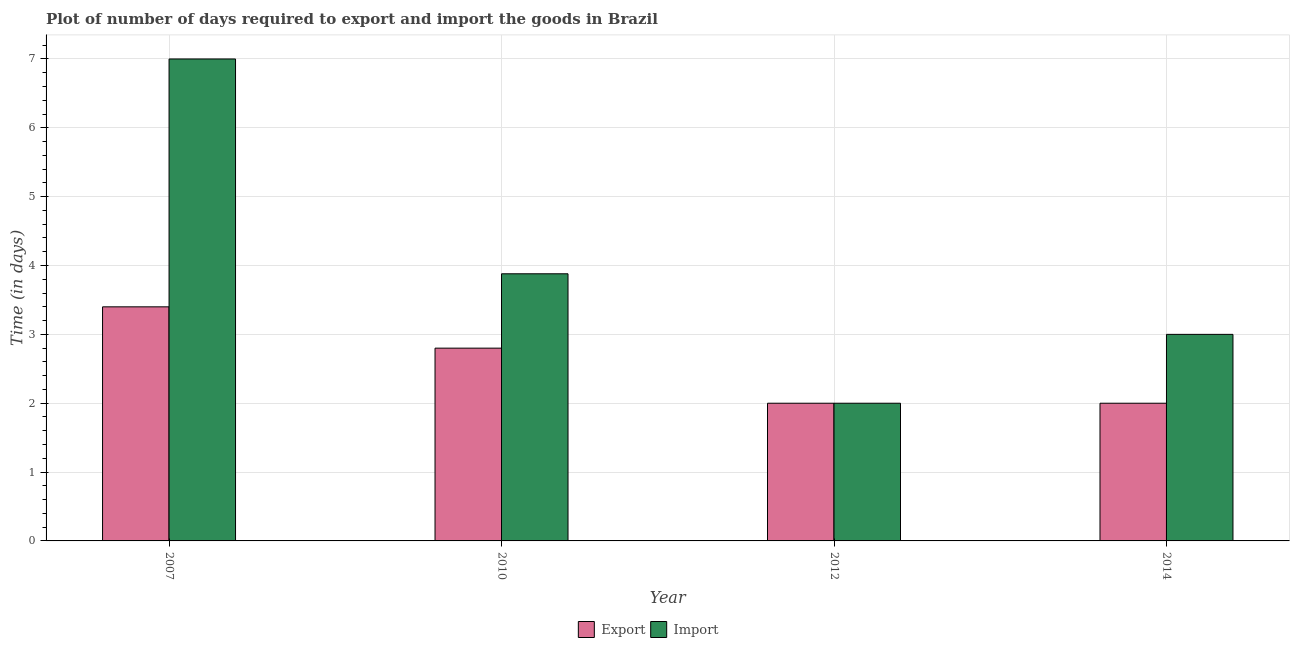How many different coloured bars are there?
Make the answer very short. 2. How many bars are there on the 2nd tick from the left?
Provide a succinct answer. 2. How many bars are there on the 1st tick from the right?
Give a very brief answer. 2. In how many cases, is the number of bars for a given year not equal to the number of legend labels?
Offer a terse response. 0. What is the time required to export in 2010?
Provide a succinct answer. 2.8. Across all years, what is the maximum time required to import?
Provide a short and direct response. 7. In which year was the time required to export minimum?
Your answer should be very brief. 2012. What is the total time required to import in the graph?
Provide a short and direct response. 15.88. What is the difference between the time required to import in 2007 and that in 2010?
Offer a terse response. 3.12. What is the difference between the time required to export in 2014 and the time required to import in 2010?
Provide a succinct answer. -0.8. What is the average time required to import per year?
Your answer should be very brief. 3.97. In the year 2007, what is the difference between the time required to import and time required to export?
Your answer should be very brief. 0. In how many years, is the time required to export greater than 4.8 days?
Give a very brief answer. 0. Is the time required to export in 2007 less than that in 2014?
Offer a very short reply. No. Is the difference between the time required to import in 2012 and 2014 greater than the difference between the time required to export in 2012 and 2014?
Provide a succinct answer. No. What is the difference between the highest and the second highest time required to export?
Provide a short and direct response. 0.6. What is the difference between the highest and the lowest time required to import?
Offer a very short reply. 5. In how many years, is the time required to export greater than the average time required to export taken over all years?
Make the answer very short. 2. What does the 1st bar from the left in 2007 represents?
Your answer should be very brief. Export. What does the 2nd bar from the right in 2010 represents?
Make the answer very short. Export. Are all the bars in the graph horizontal?
Offer a terse response. No. How many years are there in the graph?
Make the answer very short. 4. Does the graph contain any zero values?
Your answer should be very brief. No. Does the graph contain grids?
Provide a succinct answer. Yes. How are the legend labels stacked?
Give a very brief answer. Horizontal. What is the title of the graph?
Offer a very short reply. Plot of number of days required to export and import the goods in Brazil. Does "Researchers" appear as one of the legend labels in the graph?
Make the answer very short. No. What is the label or title of the Y-axis?
Provide a short and direct response. Time (in days). What is the Time (in days) of Import in 2007?
Your response must be concise. 7. What is the Time (in days) of Export in 2010?
Make the answer very short. 2.8. What is the Time (in days) of Import in 2010?
Your answer should be compact. 3.88. What is the Time (in days) in Export in 2014?
Keep it short and to the point. 2. Across all years, what is the maximum Time (in days) in Import?
Your answer should be very brief. 7. Across all years, what is the minimum Time (in days) of Export?
Your response must be concise. 2. What is the total Time (in days) in Export in the graph?
Offer a very short reply. 10.2. What is the total Time (in days) of Import in the graph?
Make the answer very short. 15.88. What is the difference between the Time (in days) of Import in 2007 and that in 2010?
Your answer should be compact. 3.12. What is the difference between the Time (in days) of Import in 2007 and that in 2012?
Provide a short and direct response. 5. What is the difference between the Time (in days) of Export in 2010 and that in 2012?
Offer a terse response. 0.8. What is the difference between the Time (in days) of Import in 2010 and that in 2012?
Provide a succinct answer. 1.88. What is the difference between the Time (in days) of Import in 2010 and that in 2014?
Your response must be concise. 0.88. What is the difference between the Time (in days) in Import in 2012 and that in 2014?
Your answer should be very brief. -1. What is the difference between the Time (in days) in Export in 2007 and the Time (in days) in Import in 2010?
Offer a very short reply. -0.48. What is the difference between the Time (in days) of Export in 2010 and the Time (in days) of Import in 2014?
Your response must be concise. -0.2. What is the average Time (in days) of Export per year?
Offer a very short reply. 2.55. What is the average Time (in days) of Import per year?
Provide a succinct answer. 3.97. In the year 2010, what is the difference between the Time (in days) in Export and Time (in days) in Import?
Provide a short and direct response. -1.08. In the year 2012, what is the difference between the Time (in days) of Export and Time (in days) of Import?
Your answer should be compact. 0. In the year 2014, what is the difference between the Time (in days) of Export and Time (in days) of Import?
Make the answer very short. -1. What is the ratio of the Time (in days) of Export in 2007 to that in 2010?
Keep it short and to the point. 1.21. What is the ratio of the Time (in days) in Import in 2007 to that in 2010?
Provide a succinct answer. 1.8. What is the ratio of the Time (in days) in Export in 2007 to that in 2012?
Keep it short and to the point. 1.7. What is the ratio of the Time (in days) of Import in 2007 to that in 2012?
Ensure brevity in your answer.  3.5. What is the ratio of the Time (in days) in Import in 2007 to that in 2014?
Make the answer very short. 2.33. What is the ratio of the Time (in days) in Import in 2010 to that in 2012?
Ensure brevity in your answer.  1.94. What is the ratio of the Time (in days) in Export in 2010 to that in 2014?
Provide a succinct answer. 1.4. What is the ratio of the Time (in days) in Import in 2010 to that in 2014?
Make the answer very short. 1.29. What is the difference between the highest and the second highest Time (in days) of Export?
Keep it short and to the point. 0.6. What is the difference between the highest and the second highest Time (in days) of Import?
Provide a succinct answer. 3.12. What is the difference between the highest and the lowest Time (in days) in Import?
Your response must be concise. 5. 